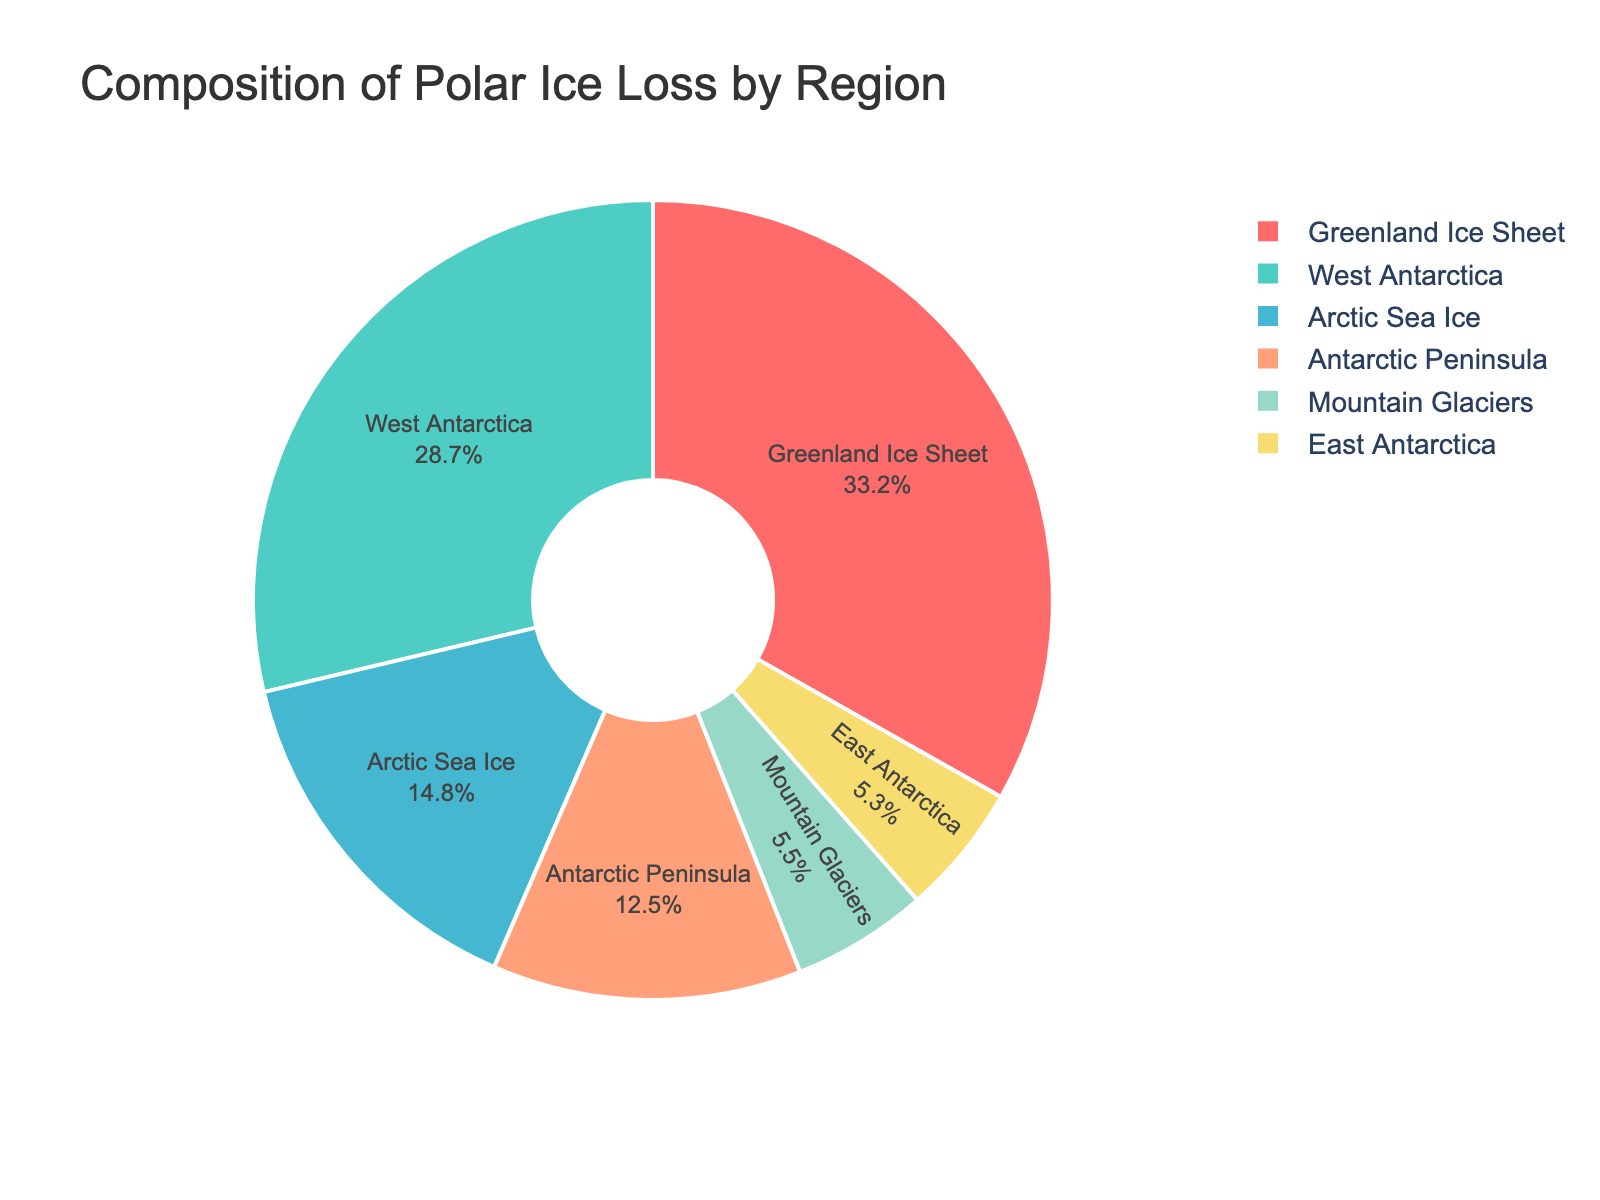Which region contributes the most to polar ice loss? By looking at the pie chart, Greenland Ice Sheet has the largest segment. Its ice loss percentage is 33.2%, which is the highest among the given regions.
Answer: Greenland Ice Sheet Which region has the second highest percentage of polar ice loss? The second largest segment in the pie chart is for West Antarctica, with an ice loss percentage of 28.7%.
Answer: West Antarctica What is the combined ice loss percentage for the Antarctic Peninsula and East Antarctica? The ice loss percentage for Antarctic Peninsula is 12.5% and for East Antarctica is 5.3%. Summing these gives 12.5 + 5.3 = 17.8%.
Answer: 17.8% Which regions contribute to over half of the total ice loss? Greenland Ice Sheet (33.2%) and West Antarctica (28.7%) together contribute 33.2 + 28.7 = 61.9%, which is over half of the total ice loss.
Answer: Greenland Ice Sheet, West Antarctica How much higher is the ice loss percentage in the Arctic Sea Ice compared to Mountain Glaciers? Arctic Sea Ice has an ice loss percentage of 14.8% and Mountain Glaciers have 5.5%. The difference is 14.8 - 5.5 = 9.3%.
Answer: 9.3% Which three regions have the smallest ice loss percentages? The pie chart shows the smallest segments for East Antarctica (5.3%), Mountain Glaciers (5.5%), and Antarctic Peninsula (12.5%).
Answer: East Antarctica, Mountain Glaciers, Antarctic Peninsula Is the ice loss percentage of the Greenland Ice Sheet more than double that of the Antarctic Peninsula? The percentage for Greenland Ice Sheet is 33.2% and for Antarctic Peninsula is 12.5%. Doubling the Antarctic Peninsula's percentage gives 2 * 12.5 = 25%. Since 33.2% is more than 25%, the statement is true.
Answer: Yes What is the approximate average ice loss percentage of all regions provided in the chart? The percentages are: 12.5, 28.7, 5.3, 33.2, 14.8, and 5.5. Summing these gives 100%. The average is 100 / 6 = 16.67%.
Answer: 16.67% Which region comes third in terms of contributing to polar ice loss? The third largest segment is Arctic Sea Ice with an ice loss percentage of 14.8%.
Answer: Arctic Sea Ice 